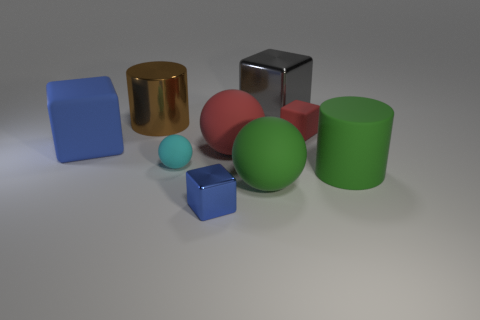There is a thing that is the same color as the large matte block; what material is it?
Give a very brief answer. Metal. There is a thing that is the same color as the big matte block; what is its size?
Provide a short and direct response. Small. What number of things are either tiny blue metal blocks or yellow rubber blocks?
Offer a very short reply. 1. What size is the blue metal object that is the same shape as the small red thing?
Offer a very short reply. Small. The blue matte cube is what size?
Provide a short and direct response. Large. Are there more shiny cubes in front of the blue rubber object than big blue rubber spheres?
Your answer should be very brief. Yes. There is a big cylinder that is to the right of the small shiny thing; is its color the same as the large sphere that is in front of the cyan matte object?
Keep it short and to the point. Yes. What material is the block that is on the left side of the blue object that is on the right side of the big cylinder on the left side of the small red matte cube?
Give a very brief answer. Rubber. Are there more blue shiny cubes than large yellow matte blocks?
Your answer should be very brief. Yes. Is there anything else that has the same color as the tiny ball?
Provide a short and direct response. No. 